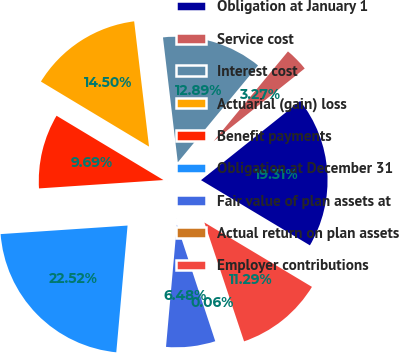<chart> <loc_0><loc_0><loc_500><loc_500><pie_chart><fcel>Obligation at January 1<fcel>Service cost<fcel>Interest cost<fcel>Actuarial (gain) loss<fcel>Benefit payments<fcel>Obligation at December 31<fcel>Fair value of plan assets at<fcel>Actual return on plan assets<fcel>Employer contributions<nl><fcel>19.31%<fcel>3.27%<fcel>12.89%<fcel>14.5%<fcel>9.69%<fcel>22.52%<fcel>6.48%<fcel>0.06%<fcel>11.29%<nl></chart> 